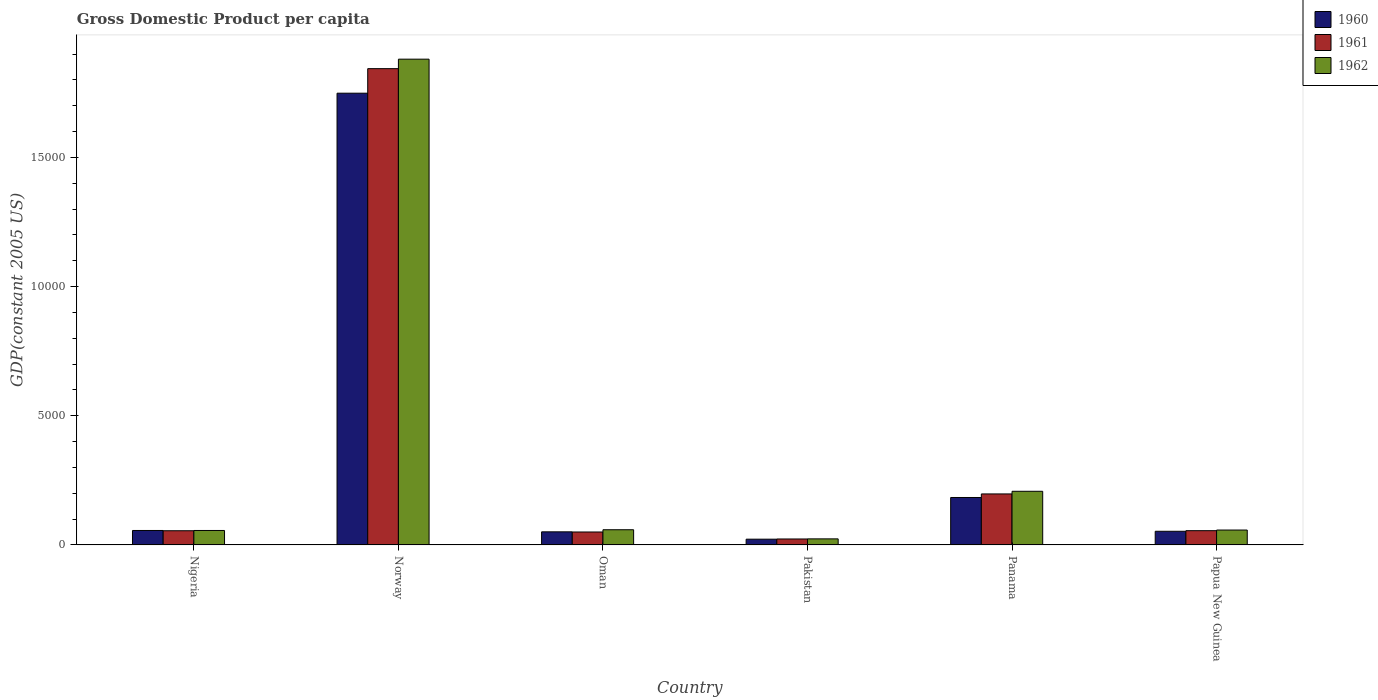How many different coloured bars are there?
Your answer should be compact. 3. How many groups of bars are there?
Make the answer very short. 6. Are the number of bars per tick equal to the number of legend labels?
Ensure brevity in your answer.  Yes. How many bars are there on the 3rd tick from the right?
Provide a short and direct response. 3. In how many cases, is the number of bars for a given country not equal to the number of legend labels?
Offer a terse response. 0. What is the GDP per capita in 1962 in Pakistan?
Ensure brevity in your answer.  234.77. Across all countries, what is the maximum GDP per capita in 1961?
Make the answer very short. 1.84e+04. Across all countries, what is the minimum GDP per capita in 1961?
Your answer should be compact. 230.24. In which country was the GDP per capita in 1960 maximum?
Give a very brief answer. Norway. What is the total GDP per capita in 1960 in the graph?
Your response must be concise. 2.11e+04. What is the difference between the GDP per capita in 1960 in Pakistan and that in Papua New Guinea?
Provide a short and direct response. -305.96. What is the difference between the GDP per capita in 1961 in Papua New Guinea and the GDP per capita in 1960 in Oman?
Give a very brief answer. 44.36. What is the average GDP per capita in 1962 per country?
Make the answer very short. 3805.86. What is the difference between the GDP per capita of/in 1961 and GDP per capita of/in 1962 in Papua New Guinea?
Offer a terse response. -24.75. What is the ratio of the GDP per capita in 1960 in Panama to that in Papua New Guinea?
Provide a succinct answer. 3.47. What is the difference between the highest and the second highest GDP per capita in 1962?
Your response must be concise. 1.82e+04. What is the difference between the highest and the lowest GDP per capita in 1961?
Your answer should be very brief. 1.82e+04. In how many countries, is the GDP per capita in 1960 greater than the average GDP per capita in 1960 taken over all countries?
Make the answer very short. 1. Is the sum of the GDP per capita in 1962 in Norway and Pakistan greater than the maximum GDP per capita in 1961 across all countries?
Your answer should be very brief. Yes. What does the 2nd bar from the left in Panama represents?
Provide a succinct answer. 1961. Is it the case that in every country, the sum of the GDP per capita in 1960 and GDP per capita in 1962 is greater than the GDP per capita in 1961?
Make the answer very short. Yes. Are all the bars in the graph horizontal?
Make the answer very short. No. Does the graph contain any zero values?
Offer a very short reply. No. How many legend labels are there?
Offer a terse response. 3. How are the legend labels stacked?
Your answer should be very brief. Vertical. What is the title of the graph?
Offer a very short reply. Gross Domestic Product per capita. What is the label or title of the Y-axis?
Your answer should be compact. GDP(constant 2005 US). What is the GDP(constant 2005 US) of 1960 in Nigeria?
Offer a terse response. 559.19. What is the GDP(constant 2005 US) in 1961 in Nigeria?
Make the answer very short. 548.94. What is the GDP(constant 2005 US) in 1962 in Nigeria?
Provide a succinct answer. 559.66. What is the GDP(constant 2005 US) in 1960 in Norway?
Your answer should be compact. 1.75e+04. What is the GDP(constant 2005 US) in 1961 in Norway?
Your answer should be compact. 1.84e+04. What is the GDP(constant 2005 US) of 1962 in Norway?
Give a very brief answer. 1.88e+04. What is the GDP(constant 2005 US) of 1960 in Oman?
Provide a succinct answer. 507.14. What is the GDP(constant 2005 US) of 1961 in Oman?
Your answer should be compact. 500.97. What is the GDP(constant 2005 US) in 1962 in Oman?
Offer a terse response. 587.62. What is the GDP(constant 2005 US) in 1960 in Pakistan?
Offer a very short reply. 222.44. What is the GDP(constant 2005 US) of 1961 in Pakistan?
Provide a short and direct response. 230.24. What is the GDP(constant 2005 US) of 1962 in Pakistan?
Keep it short and to the point. 234.77. What is the GDP(constant 2005 US) in 1960 in Panama?
Your answer should be very brief. 1836.06. What is the GDP(constant 2005 US) in 1961 in Panama?
Offer a very short reply. 1974.02. What is the GDP(constant 2005 US) of 1962 in Panama?
Your answer should be compact. 2076.28. What is the GDP(constant 2005 US) in 1960 in Papua New Guinea?
Keep it short and to the point. 528.4. What is the GDP(constant 2005 US) of 1961 in Papua New Guinea?
Offer a terse response. 551.5. What is the GDP(constant 2005 US) in 1962 in Papua New Guinea?
Give a very brief answer. 576.26. Across all countries, what is the maximum GDP(constant 2005 US) of 1960?
Ensure brevity in your answer.  1.75e+04. Across all countries, what is the maximum GDP(constant 2005 US) in 1961?
Give a very brief answer. 1.84e+04. Across all countries, what is the maximum GDP(constant 2005 US) in 1962?
Offer a very short reply. 1.88e+04. Across all countries, what is the minimum GDP(constant 2005 US) in 1960?
Keep it short and to the point. 222.44. Across all countries, what is the minimum GDP(constant 2005 US) in 1961?
Ensure brevity in your answer.  230.24. Across all countries, what is the minimum GDP(constant 2005 US) of 1962?
Offer a terse response. 234.77. What is the total GDP(constant 2005 US) in 1960 in the graph?
Provide a succinct answer. 2.11e+04. What is the total GDP(constant 2005 US) in 1961 in the graph?
Provide a succinct answer. 2.22e+04. What is the total GDP(constant 2005 US) of 1962 in the graph?
Keep it short and to the point. 2.28e+04. What is the difference between the GDP(constant 2005 US) of 1960 in Nigeria and that in Norway?
Ensure brevity in your answer.  -1.69e+04. What is the difference between the GDP(constant 2005 US) of 1961 in Nigeria and that in Norway?
Your answer should be compact. -1.79e+04. What is the difference between the GDP(constant 2005 US) of 1962 in Nigeria and that in Norway?
Your answer should be compact. -1.82e+04. What is the difference between the GDP(constant 2005 US) in 1960 in Nigeria and that in Oman?
Your response must be concise. 52.06. What is the difference between the GDP(constant 2005 US) in 1961 in Nigeria and that in Oman?
Offer a very short reply. 47.97. What is the difference between the GDP(constant 2005 US) in 1962 in Nigeria and that in Oman?
Offer a very short reply. -27.96. What is the difference between the GDP(constant 2005 US) in 1960 in Nigeria and that in Pakistan?
Your response must be concise. 336.76. What is the difference between the GDP(constant 2005 US) in 1961 in Nigeria and that in Pakistan?
Your answer should be compact. 318.71. What is the difference between the GDP(constant 2005 US) in 1962 in Nigeria and that in Pakistan?
Provide a short and direct response. 324.89. What is the difference between the GDP(constant 2005 US) in 1960 in Nigeria and that in Panama?
Your answer should be compact. -1276.87. What is the difference between the GDP(constant 2005 US) of 1961 in Nigeria and that in Panama?
Your answer should be very brief. -1425.07. What is the difference between the GDP(constant 2005 US) of 1962 in Nigeria and that in Panama?
Keep it short and to the point. -1516.62. What is the difference between the GDP(constant 2005 US) of 1960 in Nigeria and that in Papua New Guinea?
Ensure brevity in your answer.  30.79. What is the difference between the GDP(constant 2005 US) of 1961 in Nigeria and that in Papua New Guinea?
Provide a succinct answer. -2.56. What is the difference between the GDP(constant 2005 US) of 1962 in Nigeria and that in Papua New Guinea?
Give a very brief answer. -16.6. What is the difference between the GDP(constant 2005 US) of 1960 in Norway and that in Oman?
Offer a terse response. 1.70e+04. What is the difference between the GDP(constant 2005 US) of 1961 in Norway and that in Oman?
Make the answer very short. 1.79e+04. What is the difference between the GDP(constant 2005 US) in 1962 in Norway and that in Oman?
Offer a very short reply. 1.82e+04. What is the difference between the GDP(constant 2005 US) of 1960 in Norway and that in Pakistan?
Your response must be concise. 1.73e+04. What is the difference between the GDP(constant 2005 US) of 1961 in Norway and that in Pakistan?
Offer a terse response. 1.82e+04. What is the difference between the GDP(constant 2005 US) in 1962 in Norway and that in Pakistan?
Your response must be concise. 1.86e+04. What is the difference between the GDP(constant 2005 US) of 1960 in Norway and that in Panama?
Your response must be concise. 1.56e+04. What is the difference between the GDP(constant 2005 US) in 1961 in Norway and that in Panama?
Give a very brief answer. 1.65e+04. What is the difference between the GDP(constant 2005 US) of 1962 in Norway and that in Panama?
Your answer should be compact. 1.67e+04. What is the difference between the GDP(constant 2005 US) in 1960 in Norway and that in Papua New Guinea?
Your answer should be compact. 1.70e+04. What is the difference between the GDP(constant 2005 US) of 1961 in Norway and that in Papua New Guinea?
Give a very brief answer. 1.79e+04. What is the difference between the GDP(constant 2005 US) in 1962 in Norway and that in Papua New Guinea?
Provide a short and direct response. 1.82e+04. What is the difference between the GDP(constant 2005 US) of 1960 in Oman and that in Pakistan?
Make the answer very short. 284.7. What is the difference between the GDP(constant 2005 US) in 1961 in Oman and that in Pakistan?
Your answer should be very brief. 270.73. What is the difference between the GDP(constant 2005 US) in 1962 in Oman and that in Pakistan?
Your answer should be very brief. 352.85. What is the difference between the GDP(constant 2005 US) of 1960 in Oman and that in Panama?
Give a very brief answer. -1328.92. What is the difference between the GDP(constant 2005 US) of 1961 in Oman and that in Panama?
Provide a succinct answer. -1473.05. What is the difference between the GDP(constant 2005 US) in 1962 in Oman and that in Panama?
Keep it short and to the point. -1488.67. What is the difference between the GDP(constant 2005 US) in 1960 in Oman and that in Papua New Guinea?
Provide a succinct answer. -21.26. What is the difference between the GDP(constant 2005 US) in 1961 in Oman and that in Papua New Guinea?
Your answer should be compact. -50.53. What is the difference between the GDP(constant 2005 US) of 1962 in Oman and that in Papua New Guinea?
Keep it short and to the point. 11.36. What is the difference between the GDP(constant 2005 US) of 1960 in Pakistan and that in Panama?
Make the answer very short. -1613.62. What is the difference between the GDP(constant 2005 US) of 1961 in Pakistan and that in Panama?
Provide a short and direct response. -1743.78. What is the difference between the GDP(constant 2005 US) of 1962 in Pakistan and that in Panama?
Provide a succinct answer. -1841.51. What is the difference between the GDP(constant 2005 US) of 1960 in Pakistan and that in Papua New Guinea?
Make the answer very short. -305.96. What is the difference between the GDP(constant 2005 US) in 1961 in Pakistan and that in Papua New Guinea?
Your answer should be compact. -321.26. What is the difference between the GDP(constant 2005 US) of 1962 in Pakistan and that in Papua New Guinea?
Provide a short and direct response. -341.49. What is the difference between the GDP(constant 2005 US) of 1960 in Panama and that in Papua New Guinea?
Your response must be concise. 1307.66. What is the difference between the GDP(constant 2005 US) in 1961 in Panama and that in Papua New Guinea?
Provide a short and direct response. 1422.51. What is the difference between the GDP(constant 2005 US) of 1962 in Panama and that in Papua New Guinea?
Give a very brief answer. 1500.03. What is the difference between the GDP(constant 2005 US) of 1960 in Nigeria and the GDP(constant 2005 US) of 1961 in Norway?
Provide a short and direct response. -1.79e+04. What is the difference between the GDP(constant 2005 US) in 1960 in Nigeria and the GDP(constant 2005 US) in 1962 in Norway?
Give a very brief answer. -1.82e+04. What is the difference between the GDP(constant 2005 US) in 1961 in Nigeria and the GDP(constant 2005 US) in 1962 in Norway?
Provide a short and direct response. -1.83e+04. What is the difference between the GDP(constant 2005 US) in 1960 in Nigeria and the GDP(constant 2005 US) in 1961 in Oman?
Your answer should be compact. 58.22. What is the difference between the GDP(constant 2005 US) in 1960 in Nigeria and the GDP(constant 2005 US) in 1962 in Oman?
Provide a short and direct response. -28.42. What is the difference between the GDP(constant 2005 US) in 1961 in Nigeria and the GDP(constant 2005 US) in 1962 in Oman?
Provide a short and direct response. -38.67. What is the difference between the GDP(constant 2005 US) of 1960 in Nigeria and the GDP(constant 2005 US) of 1961 in Pakistan?
Keep it short and to the point. 328.96. What is the difference between the GDP(constant 2005 US) in 1960 in Nigeria and the GDP(constant 2005 US) in 1962 in Pakistan?
Provide a short and direct response. 324.43. What is the difference between the GDP(constant 2005 US) of 1961 in Nigeria and the GDP(constant 2005 US) of 1962 in Pakistan?
Ensure brevity in your answer.  314.18. What is the difference between the GDP(constant 2005 US) in 1960 in Nigeria and the GDP(constant 2005 US) in 1961 in Panama?
Give a very brief answer. -1414.82. What is the difference between the GDP(constant 2005 US) of 1960 in Nigeria and the GDP(constant 2005 US) of 1962 in Panama?
Make the answer very short. -1517.09. What is the difference between the GDP(constant 2005 US) in 1961 in Nigeria and the GDP(constant 2005 US) in 1962 in Panama?
Ensure brevity in your answer.  -1527.34. What is the difference between the GDP(constant 2005 US) in 1960 in Nigeria and the GDP(constant 2005 US) in 1961 in Papua New Guinea?
Offer a terse response. 7.69. What is the difference between the GDP(constant 2005 US) of 1960 in Nigeria and the GDP(constant 2005 US) of 1962 in Papua New Guinea?
Offer a terse response. -17.06. What is the difference between the GDP(constant 2005 US) in 1961 in Nigeria and the GDP(constant 2005 US) in 1962 in Papua New Guinea?
Provide a succinct answer. -27.31. What is the difference between the GDP(constant 2005 US) of 1960 in Norway and the GDP(constant 2005 US) of 1961 in Oman?
Make the answer very short. 1.70e+04. What is the difference between the GDP(constant 2005 US) in 1960 in Norway and the GDP(constant 2005 US) in 1962 in Oman?
Offer a very short reply. 1.69e+04. What is the difference between the GDP(constant 2005 US) in 1961 in Norway and the GDP(constant 2005 US) in 1962 in Oman?
Your answer should be very brief. 1.78e+04. What is the difference between the GDP(constant 2005 US) of 1960 in Norway and the GDP(constant 2005 US) of 1961 in Pakistan?
Ensure brevity in your answer.  1.73e+04. What is the difference between the GDP(constant 2005 US) in 1960 in Norway and the GDP(constant 2005 US) in 1962 in Pakistan?
Make the answer very short. 1.72e+04. What is the difference between the GDP(constant 2005 US) in 1961 in Norway and the GDP(constant 2005 US) in 1962 in Pakistan?
Your answer should be very brief. 1.82e+04. What is the difference between the GDP(constant 2005 US) in 1960 in Norway and the GDP(constant 2005 US) in 1961 in Panama?
Keep it short and to the point. 1.55e+04. What is the difference between the GDP(constant 2005 US) of 1960 in Norway and the GDP(constant 2005 US) of 1962 in Panama?
Your answer should be compact. 1.54e+04. What is the difference between the GDP(constant 2005 US) in 1961 in Norway and the GDP(constant 2005 US) in 1962 in Panama?
Provide a succinct answer. 1.64e+04. What is the difference between the GDP(constant 2005 US) in 1960 in Norway and the GDP(constant 2005 US) in 1961 in Papua New Guinea?
Your response must be concise. 1.69e+04. What is the difference between the GDP(constant 2005 US) in 1960 in Norway and the GDP(constant 2005 US) in 1962 in Papua New Guinea?
Your answer should be very brief. 1.69e+04. What is the difference between the GDP(constant 2005 US) of 1961 in Norway and the GDP(constant 2005 US) of 1962 in Papua New Guinea?
Your response must be concise. 1.79e+04. What is the difference between the GDP(constant 2005 US) in 1960 in Oman and the GDP(constant 2005 US) in 1961 in Pakistan?
Provide a short and direct response. 276.9. What is the difference between the GDP(constant 2005 US) of 1960 in Oman and the GDP(constant 2005 US) of 1962 in Pakistan?
Offer a very short reply. 272.37. What is the difference between the GDP(constant 2005 US) in 1961 in Oman and the GDP(constant 2005 US) in 1962 in Pakistan?
Ensure brevity in your answer.  266.2. What is the difference between the GDP(constant 2005 US) of 1960 in Oman and the GDP(constant 2005 US) of 1961 in Panama?
Your answer should be compact. -1466.88. What is the difference between the GDP(constant 2005 US) of 1960 in Oman and the GDP(constant 2005 US) of 1962 in Panama?
Ensure brevity in your answer.  -1569.14. What is the difference between the GDP(constant 2005 US) of 1961 in Oman and the GDP(constant 2005 US) of 1962 in Panama?
Ensure brevity in your answer.  -1575.31. What is the difference between the GDP(constant 2005 US) in 1960 in Oman and the GDP(constant 2005 US) in 1961 in Papua New Guinea?
Your answer should be very brief. -44.36. What is the difference between the GDP(constant 2005 US) in 1960 in Oman and the GDP(constant 2005 US) in 1962 in Papua New Guinea?
Your answer should be very brief. -69.12. What is the difference between the GDP(constant 2005 US) of 1961 in Oman and the GDP(constant 2005 US) of 1962 in Papua New Guinea?
Your answer should be compact. -75.28. What is the difference between the GDP(constant 2005 US) in 1960 in Pakistan and the GDP(constant 2005 US) in 1961 in Panama?
Ensure brevity in your answer.  -1751.58. What is the difference between the GDP(constant 2005 US) of 1960 in Pakistan and the GDP(constant 2005 US) of 1962 in Panama?
Keep it short and to the point. -1853.84. What is the difference between the GDP(constant 2005 US) of 1961 in Pakistan and the GDP(constant 2005 US) of 1962 in Panama?
Your answer should be very brief. -1846.04. What is the difference between the GDP(constant 2005 US) in 1960 in Pakistan and the GDP(constant 2005 US) in 1961 in Papua New Guinea?
Ensure brevity in your answer.  -329.06. What is the difference between the GDP(constant 2005 US) in 1960 in Pakistan and the GDP(constant 2005 US) in 1962 in Papua New Guinea?
Offer a terse response. -353.82. What is the difference between the GDP(constant 2005 US) in 1961 in Pakistan and the GDP(constant 2005 US) in 1962 in Papua New Guinea?
Keep it short and to the point. -346.02. What is the difference between the GDP(constant 2005 US) in 1960 in Panama and the GDP(constant 2005 US) in 1961 in Papua New Guinea?
Make the answer very short. 1284.56. What is the difference between the GDP(constant 2005 US) of 1960 in Panama and the GDP(constant 2005 US) of 1962 in Papua New Guinea?
Make the answer very short. 1259.81. What is the difference between the GDP(constant 2005 US) in 1961 in Panama and the GDP(constant 2005 US) in 1962 in Papua New Guinea?
Give a very brief answer. 1397.76. What is the average GDP(constant 2005 US) of 1960 per country?
Provide a short and direct response. 3522.83. What is the average GDP(constant 2005 US) of 1961 per country?
Ensure brevity in your answer.  3706.53. What is the average GDP(constant 2005 US) in 1962 per country?
Give a very brief answer. 3805.86. What is the difference between the GDP(constant 2005 US) in 1960 and GDP(constant 2005 US) in 1961 in Nigeria?
Offer a terse response. 10.25. What is the difference between the GDP(constant 2005 US) of 1960 and GDP(constant 2005 US) of 1962 in Nigeria?
Provide a succinct answer. -0.46. What is the difference between the GDP(constant 2005 US) in 1961 and GDP(constant 2005 US) in 1962 in Nigeria?
Ensure brevity in your answer.  -10.71. What is the difference between the GDP(constant 2005 US) in 1960 and GDP(constant 2005 US) in 1961 in Norway?
Offer a terse response. -949.8. What is the difference between the GDP(constant 2005 US) in 1960 and GDP(constant 2005 US) in 1962 in Norway?
Your response must be concise. -1316.86. What is the difference between the GDP(constant 2005 US) in 1961 and GDP(constant 2005 US) in 1962 in Norway?
Provide a short and direct response. -367.06. What is the difference between the GDP(constant 2005 US) of 1960 and GDP(constant 2005 US) of 1961 in Oman?
Provide a short and direct response. 6.17. What is the difference between the GDP(constant 2005 US) of 1960 and GDP(constant 2005 US) of 1962 in Oman?
Ensure brevity in your answer.  -80.48. What is the difference between the GDP(constant 2005 US) of 1961 and GDP(constant 2005 US) of 1962 in Oman?
Ensure brevity in your answer.  -86.64. What is the difference between the GDP(constant 2005 US) of 1960 and GDP(constant 2005 US) of 1961 in Pakistan?
Provide a succinct answer. -7.8. What is the difference between the GDP(constant 2005 US) in 1960 and GDP(constant 2005 US) in 1962 in Pakistan?
Keep it short and to the point. -12.33. What is the difference between the GDP(constant 2005 US) of 1961 and GDP(constant 2005 US) of 1962 in Pakistan?
Your response must be concise. -4.53. What is the difference between the GDP(constant 2005 US) of 1960 and GDP(constant 2005 US) of 1961 in Panama?
Your answer should be very brief. -137.96. What is the difference between the GDP(constant 2005 US) in 1960 and GDP(constant 2005 US) in 1962 in Panama?
Offer a terse response. -240.22. What is the difference between the GDP(constant 2005 US) of 1961 and GDP(constant 2005 US) of 1962 in Panama?
Make the answer very short. -102.27. What is the difference between the GDP(constant 2005 US) of 1960 and GDP(constant 2005 US) of 1961 in Papua New Guinea?
Keep it short and to the point. -23.1. What is the difference between the GDP(constant 2005 US) in 1960 and GDP(constant 2005 US) in 1962 in Papua New Guinea?
Ensure brevity in your answer.  -47.85. What is the difference between the GDP(constant 2005 US) in 1961 and GDP(constant 2005 US) in 1962 in Papua New Guinea?
Offer a terse response. -24.75. What is the ratio of the GDP(constant 2005 US) in 1960 in Nigeria to that in Norway?
Provide a succinct answer. 0.03. What is the ratio of the GDP(constant 2005 US) in 1961 in Nigeria to that in Norway?
Offer a terse response. 0.03. What is the ratio of the GDP(constant 2005 US) in 1962 in Nigeria to that in Norway?
Offer a terse response. 0.03. What is the ratio of the GDP(constant 2005 US) of 1960 in Nigeria to that in Oman?
Offer a very short reply. 1.1. What is the ratio of the GDP(constant 2005 US) of 1961 in Nigeria to that in Oman?
Provide a succinct answer. 1.1. What is the ratio of the GDP(constant 2005 US) in 1962 in Nigeria to that in Oman?
Provide a succinct answer. 0.95. What is the ratio of the GDP(constant 2005 US) in 1960 in Nigeria to that in Pakistan?
Provide a succinct answer. 2.51. What is the ratio of the GDP(constant 2005 US) of 1961 in Nigeria to that in Pakistan?
Give a very brief answer. 2.38. What is the ratio of the GDP(constant 2005 US) in 1962 in Nigeria to that in Pakistan?
Give a very brief answer. 2.38. What is the ratio of the GDP(constant 2005 US) in 1960 in Nigeria to that in Panama?
Keep it short and to the point. 0.3. What is the ratio of the GDP(constant 2005 US) in 1961 in Nigeria to that in Panama?
Offer a very short reply. 0.28. What is the ratio of the GDP(constant 2005 US) of 1962 in Nigeria to that in Panama?
Ensure brevity in your answer.  0.27. What is the ratio of the GDP(constant 2005 US) in 1960 in Nigeria to that in Papua New Guinea?
Keep it short and to the point. 1.06. What is the ratio of the GDP(constant 2005 US) of 1962 in Nigeria to that in Papua New Guinea?
Offer a terse response. 0.97. What is the ratio of the GDP(constant 2005 US) of 1960 in Norway to that in Oman?
Offer a terse response. 34.48. What is the ratio of the GDP(constant 2005 US) of 1961 in Norway to that in Oman?
Ensure brevity in your answer.  36.8. What is the ratio of the GDP(constant 2005 US) of 1962 in Norway to that in Oman?
Offer a terse response. 31.99. What is the ratio of the GDP(constant 2005 US) in 1960 in Norway to that in Pakistan?
Keep it short and to the point. 78.6. What is the ratio of the GDP(constant 2005 US) in 1961 in Norway to that in Pakistan?
Give a very brief answer. 80.06. What is the ratio of the GDP(constant 2005 US) of 1962 in Norway to that in Pakistan?
Your answer should be very brief. 80.08. What is the ratio of the GDP(constant 2005 US) in 1960 in Norway to that in Panama?
Ensure brevity in your answer.  9.52. What is the ratio of the GDP(constant 2005 US) in 1961 in Norway to that in Panama?
Provide a short and direct response. 9.34. What is the ratio of the GDP(constant 2005 US) in 1962 in Norway to that in Panama?
Give a very brief answer. 9.05. What is the ratio of the GDP(constant 2005 US) in 1960 in Norway to that in Papua New Guinea?
Give a very brief answer. 33.09. What is the ratio of the GDP(constant 2005 US) of 1961 in Norway to that in Papua New Guinea?
Keep it short and to the point. 33.42. What is the ratio of the GDP(constant 2005 US) in 1962 in Norway to that in Papua New Guinea?
Your answer should be very brief. 32.63. What is the ratio of the GDP(constant 2005 US) of 1960 in Oman to that in Pakistan?
Your answer should be compact. 2.28. What is the ratio of the GDP(constant 2005 US) in 1961 in Oman to that in Pakistan?
Your answer should be compact. 2.18. What is the ratio of the GDP(constant 2005 US) of 1962 in Oman to that in Pakistan?
Make the answer very short. 2.5. What is the ratio of the GDP(constant 2005 US) of 1960 in Oman to that in Panama?
Offer a very short reply. 0.28. What is the ratio of the GDP(constant 2005 US) in 1961 in Oman to that in Panama?
Provide a short and direct response. 0.25. What is the ratio of the GDP(constant 2005 US) in 1962 in Oman to that in Panama?
Your answer should be compact. 0.28. What is the ratio of the GDP(constant 2005 US) of 1960 in Oman to that in Papua New Guinea?
Make the answer very short. 0.96. What is the ratio of the GDP(constant 2005 US) in 1961 in Oman to that in Papua New Guinea?
Your response must be concise. 0.91. What is the ratio of the GDP(constant 2005 US) of 1962 in Oman to that in Papua New Guinea?
Provide a short and direct response. 1.02. What is the ratio of the GDP(constant 2005 US) in 1960 in Pakistan to that in Panama?
Make the answer very short. 0.12. What is the ratio of the GDP(constant 2005 US) of 1961 in Pakistan to that in Panama?
Your answer should be compact. 0.12. What is the ratio of the GDP(constant 2005 US) in 1962 in Pakistan to that in Panama?
Offer a very short reply. 0.11. What is the ratio of the GDP(constant 2005 US) of 1960 in Pakistan to that in Papua New Guinea?
Your answer should be compact. 0.42. What is the ratio of the GDP(constant 2005 US) in 1961 in Pakistan to that in Papua New Guinea?
Offer a terse response. 0.42. What is the ratio of the GDP(constant 2005 US) in 1962 in Pakistan to that in Papua New Guinea?
Your answer should be very brief. 0.41. What is the ratio of the GDP(constant 2005 US) in 1960 in Panama to that in Papua New Guinea?
Provide a succinct answer. 3.47. What is the ratio of the GDP(constant 2005 US) in 1961 in Panama to that in Papua New Guinea?
Your response must be concise. 3.58. What is the ratio of the GDP(constant 2005 US) of 1962 in Panama to that in Papua New Guinea?
Ensure brevity in your answer.  3.6. What is the difference between the highest and the second highest GDP(constant 2005 US) in 1960?
Provide a short and direct response. 1.56e+04. What is the difference between the highest and the second highest GDP(constant 2005 US) in 1961?
Provide a short and direct response. 1.65e+04. What is the difference between the highest and the second highest GDP(constant 2005 US) in 1962?
Your answer should be compact. 1.67e+04. What is the difference between the highest and the lowest GDP(constant 2005 US) in 1960?
Keep it short and to the point. 1.73e+04. What is the difference between the highest and the lowest GDP(constant 2005 US) of 1961?
Your response must be concise. 1.82e+04. What is the difference between the highest and the lowest GDP(constant 2005 US) of 1962?
Your answer should be compact. 1.86e+04. 